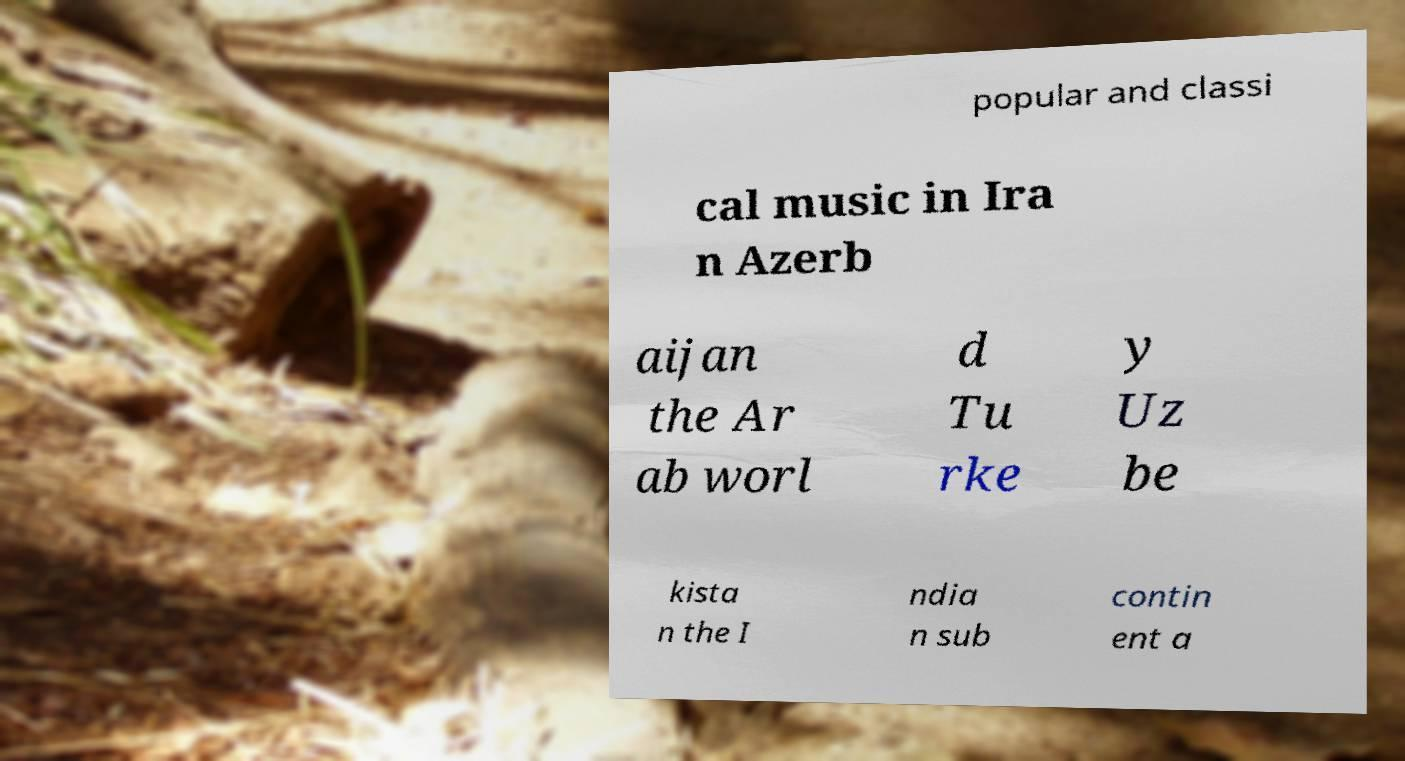Please identify and transcribe the text found in this image. popular and classi cal music in Ira n Azerb aijan the Ar ab worl d Tu rke y Uz be kista n the I ndia n sub contin ent a 